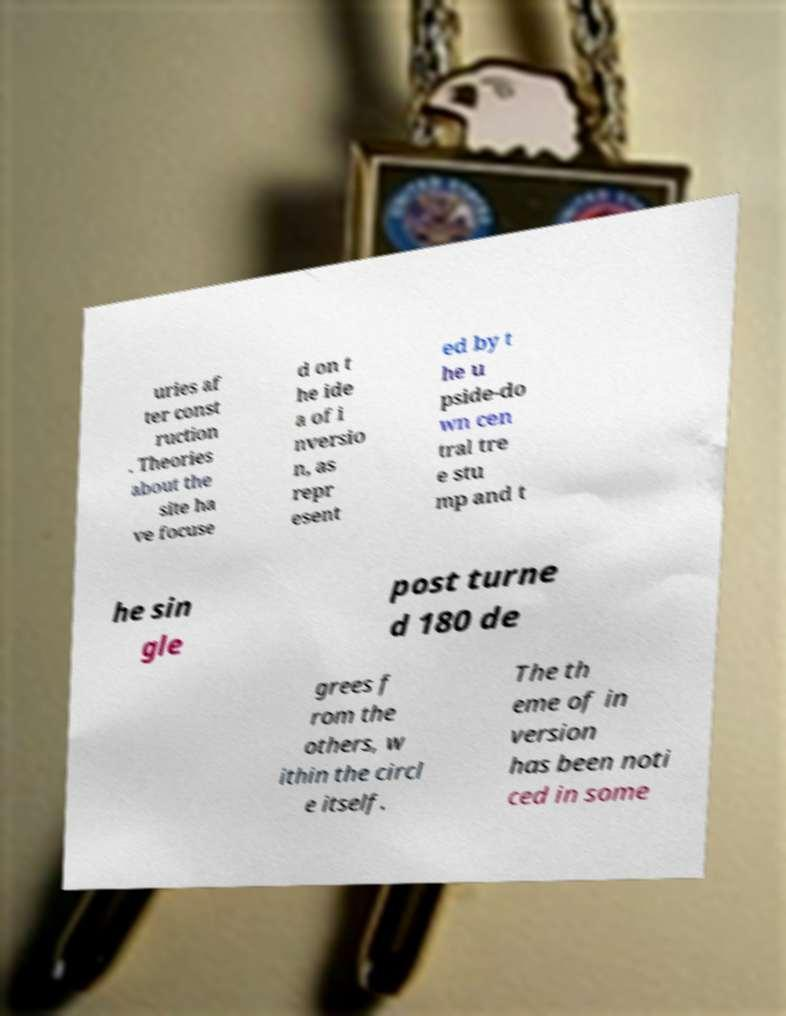There's text embedded in this image that I need extracted. Can you transcribe it verbatim? uries af ter const ruction . Theories about the site ha ve focuse d on t he ide a of i nversio n, as repr esent ed by t he u pside-do wn cen tral tre e stu mp and t he sin gle post turne d 180 de grees f rom the others, w ithin the circl e itself. The th eme of in version has been noti ced in some 